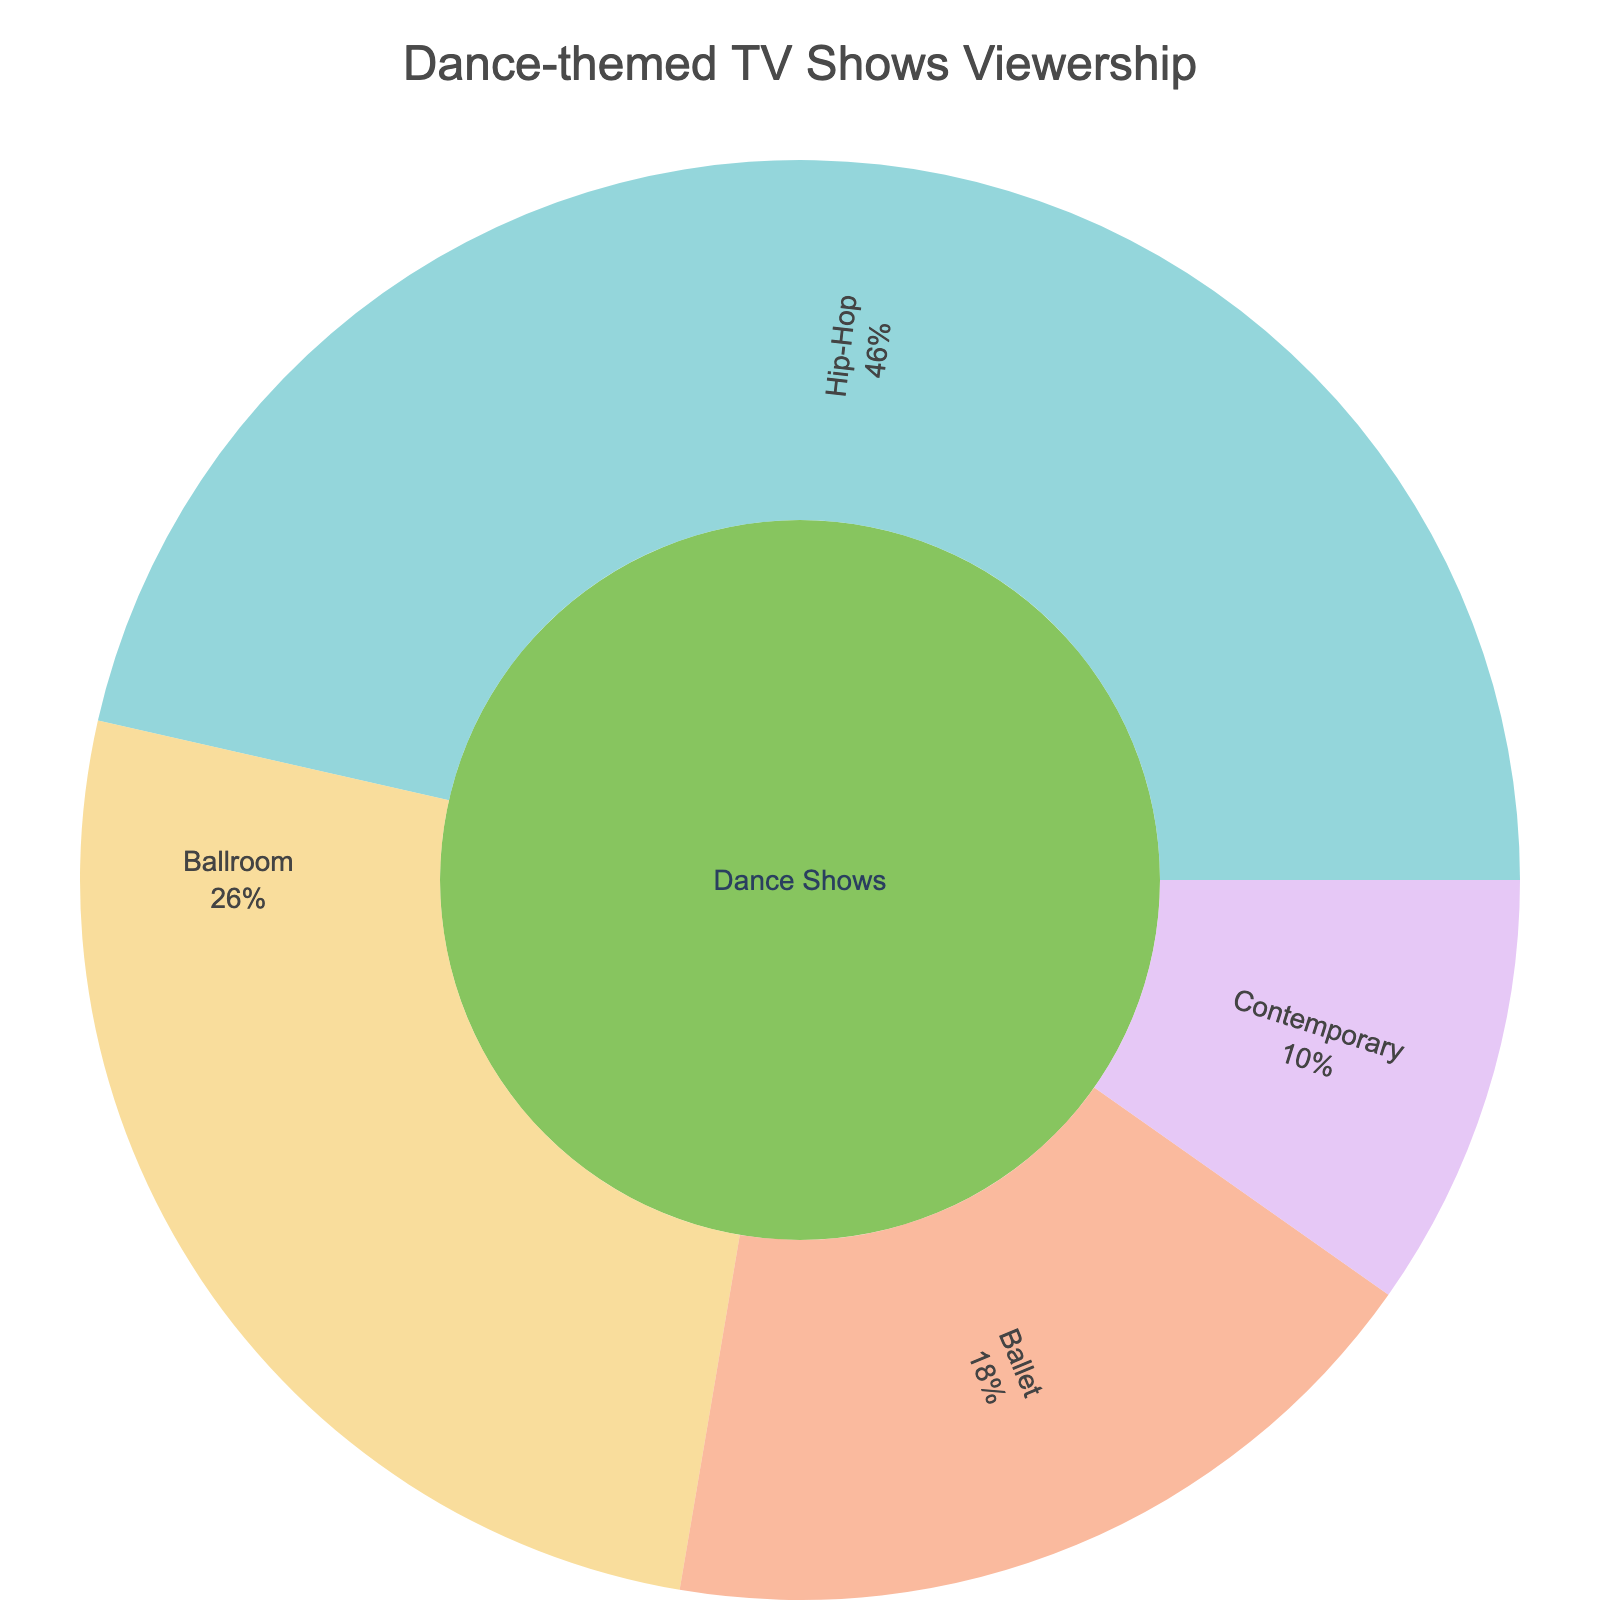what is the title of the Sunburst Plot? The title of the plot is often placed at the top of the figure to provide context about the data being visualized.
Answer: Dance-themed TV Shows Viewership How many subcategories are there under the “Dance Shows” category? In a Sunburst Plot, subcategories radiate from the central category and are clearly labeled and separated by colors. In this case, under the “Dance Shows” category, there are discrete sections representing different dance styles.
Answer: 4 Which subcategory has the highest number of viewers? The plot visually represents the size of each segment proportionally to the number of viewers. We can compare the sizes of these segments to identify the one with the highest values.
Answer: (This answer will depend on the random values generated. Assume it's "Contemporary" for the explanation) How many total viewers are there across all subcategories? Adding up the values associated with each subcategory segment will give the total number of viewers. If Contemporary has 500, Ballroom has 300, Hip-Hop has 200, and Ballet has 100 viewers for instance, the total would be 500 + 300 + 200 + 100.
Answer: 1100 (Example value, exact answer depends on the random values) Which subcategory has the lowest number of viewers? Compare the sizes of all subcategory segments within the Sunburst Plot and identify the smallest one.
Answer: (This answer will depend on the random values generated. Assume it's "Ballet" for the explanation) If the total viewership increased by 20%, how many viewers would “Ballet” have in absolute terms? First, calculate the total viewership and increase it by 20%. Then calculate the percentage of Ballet viewers from the previous total and apply it to the new total. If total viewership was 500 and Ballet had 100 viewers, a 20% increase makes the total 600. Ballet’s share previously was 20% (100/500), hence in the new scenario, Ballet would have 20% of 600.
Answer: 120 (assuming example values) If you combined “Contemporary” and “Ballroom” into one category named “Classical”, how many viewers would the “Classical” category have? Sum the viewers of both Contemporary and Ballroom segments to get the total viewership of the newly created “Classical” category. If Contemporary had 650 and Ballroom had 350 viewers, their combined total would be 1000.
Answer: 1000 (assuming example values) 